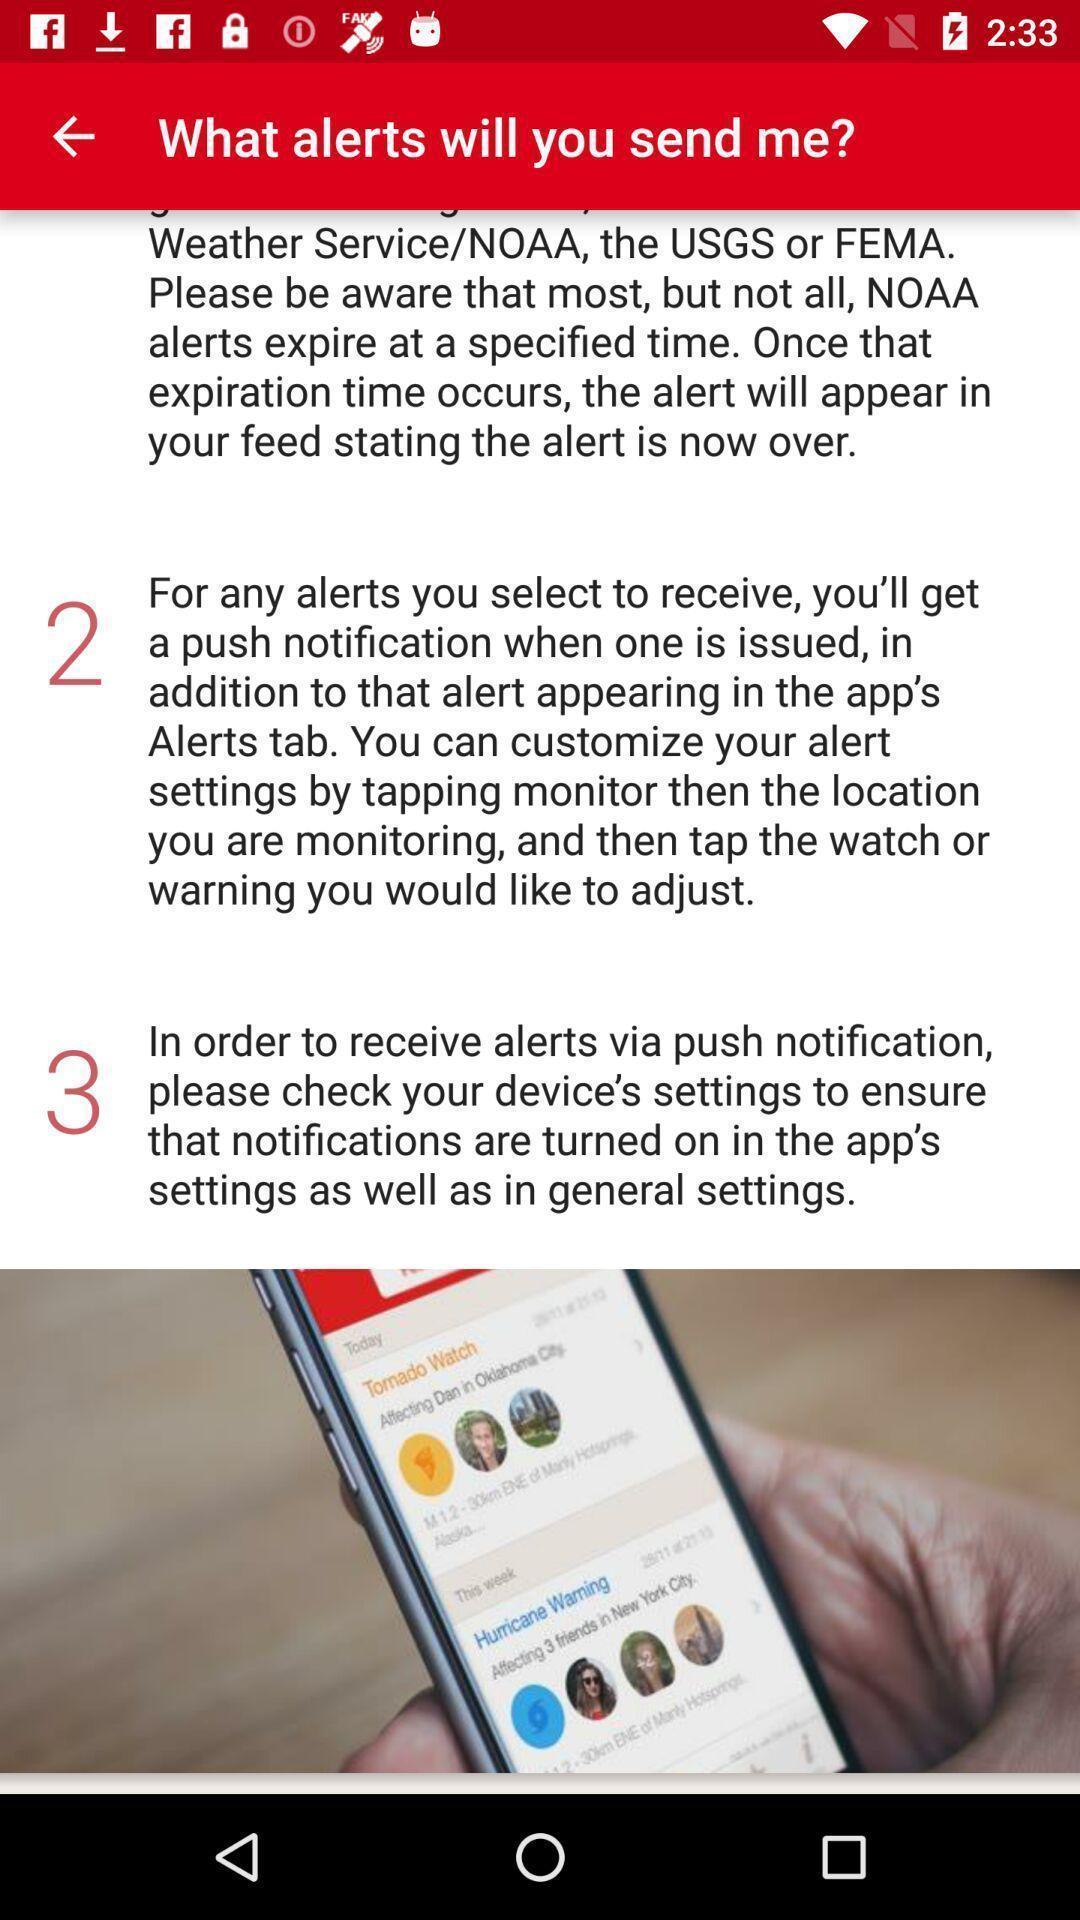What is the overall content of this screenshot? Page of a disaster alert app. 